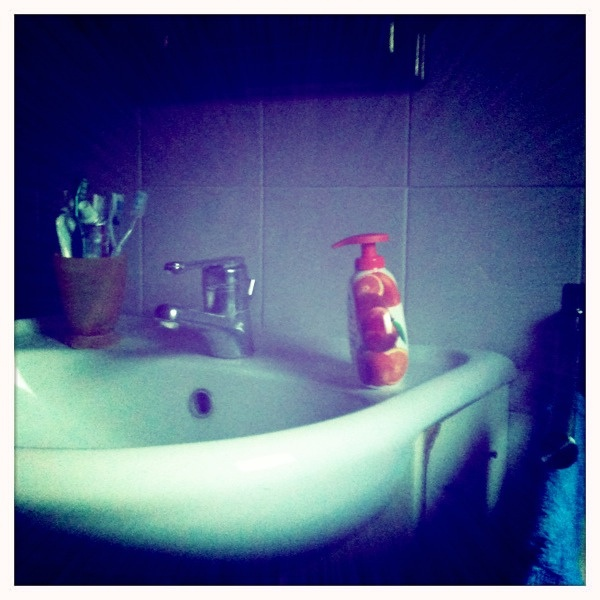Describe the objects in this image and their specific colors. I can see sink in white, lightblue, and aquamarine tones, bottle in white and purple tones, cup in white, navy, and purple tones, toothbrush in white, gray, blue, and darkblue tones, and toothbrush in white, teal, gray, and blue tones in this image. 